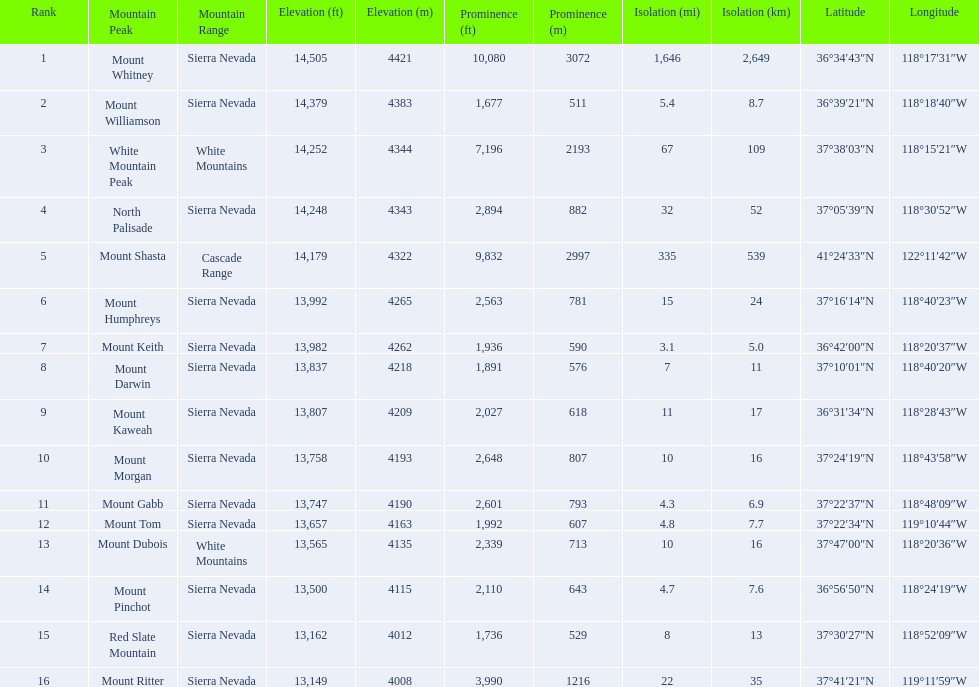What are the heights of the peaks? 14,505 ft\n4421 m, 14,379 ft\n4383 m, 14,252 ft\n4344 m, 14,248 ft\n4343 m, 14,179 ft\n4322 m, 13,992 ft\n4265 m, 13,982 ft\n4262 m, 13,837 ft\n4218 m, 13,807 ft\n4209 m, 13,758 ft\n4193 m, 13,747 ft\n4190 m, 13,657 ft\n4163 m, 13,565 ft\n4135 m, 13,500 ft\n4115 m, 13,162 ft\n4012 m, 13,149 ft\n4008 m. Which of these heights is tallest? 14,505 ft\n4421 m. What peak is 14,505 feet? Mount Whitney. 